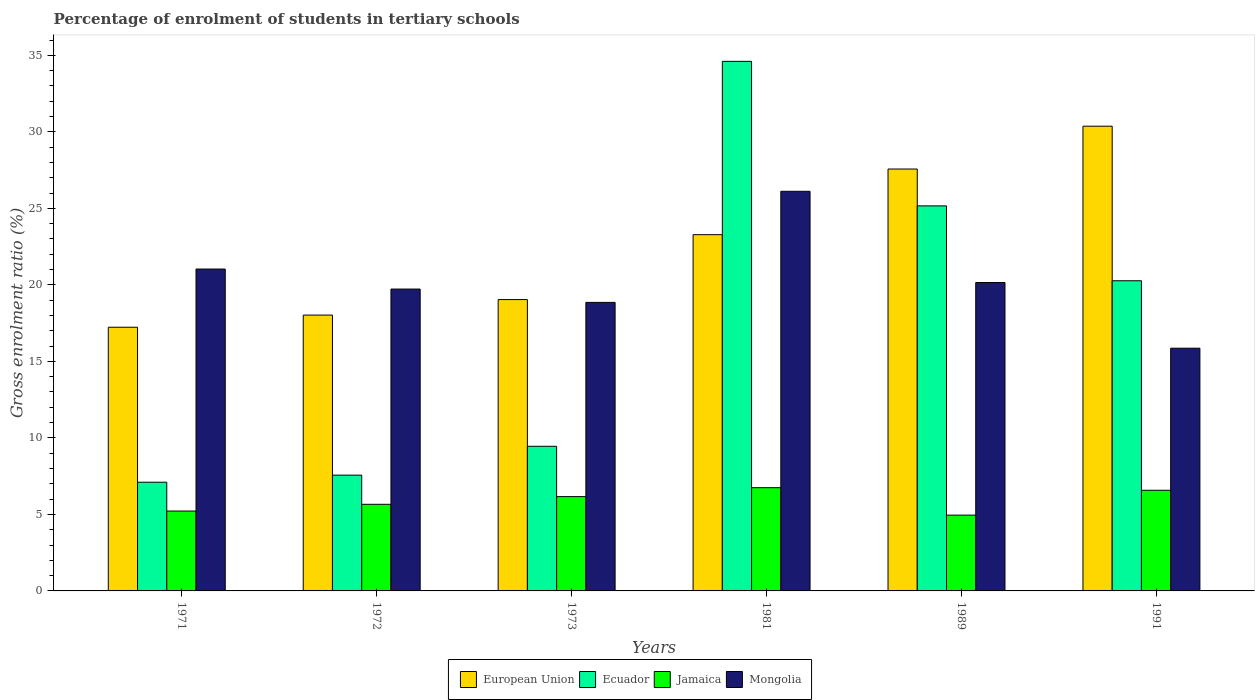How many different coloured bars are there?
Your response must be concise. 4. How many groups of bars are there?
Offer a terse response. 6. How many bars are there on the 2nd tick from the left?
Provide a succinct answer. 4. In how many cases, is the number of bars for a given year not equal to the number of legend labels?
Provide a succinct answer. 0. What is the percentage of students enrolled in tertiary schools in European Union in 1989?
Make the answer very short. 27.57. Across all years, what is the maximum percentage of students enrolled in tertiary schools in Mongolia?
Ensure brevity in your answer.  26.12. Across all years, what is the minimum percentage of students enrolled in tertiary schools in European Union?
Offer a terse response. 17.23. In which year was the percentage of students enrolled in tertiary schools in Ecuador maximum?
Your answer should be compact. 1981. In which year was the percentage of students enrolled in tertiary schools in European Union minimum?
Give a very brief answer. 1971. What is the total percentage of students enrolled in tertiary schools in Ecuador in the graph?
Give a very brief answer. 104.16. What is the difference between the percentage of students enrolled in tertiary schools in European Union in 1973 and that in 1989?
Make the answer very short. -8.53. What is the difference between the percentage of students enrolled in tertiary schools in Mongolia in 1991 and the percentage of students enrolled in tertiary schools in Ecuador in 1972?
Make the answer very short. 8.3. What is the average percentage of students enrolled in tertiary schools in Jamaica per year?
Give a very brief answer. 5.89. In the year 1981, what is the difference between the percentage of students enrolled in tertiary schools in Mongolia and percentage of students enrolled in tertiary schools in Ecuador?
Provide a succinct answer. -8.49. What is the ratio of the percentage of students enrolled in tertiary schools in European Union in 1972 to that in 1989?
Your response must be concise. 0.65. Is the difference between the percentage of students enrolled in tertiary schools in Mongolia in 1989 and 1991 greater than the difference between the percentage of students enrolled in tertiary schools in Ecuador in 1989 and 1991?
Your response must be concise. No. What is the difference between the highest and the second highest percentage of students enrolled in tertiary schools in European Union?
Offer a very short reply. 2.8. What is the difference between the highest and the lowest percentage of students enrolled in tertiary schools in Ecuador?
Your answer should be very brief. 27.5. In how many years, is the percentage of students enrolled in tertiary schools in European Union greater than the average percentage of students enrolled in tertiary schools in European Union taken over all years?
Your response must be concise. 3. Is the sum of the percentage of students enrolled in tertiary schools in Mongolia in 1989 and 1991 greater than the maximum percentage of students enrolled in tertiary schools in Ecuador across all years?
Ensure brevity in your answer.  Yes. Is it the case that in every year, the sum of the percentage of students enrolled in tertiary schools in Mongolia and percentage of students enrolled in tertiary schools in Jamaica is greater than the sum of percentage of students enrolled in tertiary schools in Ecuador and percentage of students enrolled in tertiary schools in European Union?
Offer a very short reply. No. What does the 2nd bar from the right in 1972 represents?
Provide a succinct answer. Jamaica. Is it the case that in every year, the sum of the percentage of students enrolled in tertiary schools in Jamaica and percentage of students enrolled in tertiary schools in European Union is greater than the percentage of students enrolled in tertiary schools in Mongolia?
Your answer should be compact. Yes. How many bars are there?
Your answer should be compact. 24. Are all the bars in the graph horizontal?
Give a very brief answer. No. How many years are there in the graph?
Provide a short and direct response. 6. What is the difference between two consecutive major ticks on the Y-axis?
Give a very brief answer. 5. What is the title of the graph?
Provide a succinct answer. Percentage of enrolment of students in tertiary schools. Does "American Samoa" appear as one of the legend labels in the graph?
Offer a very short reply. No. What is the label or title of the X-axis?
Provide a short and direct response. Years. What is the Gross enrolment ratio (%) in European Union in 1971?
Provide a short and direct response. 17.23. What is the Gross enrolment ratio (%) in Ecuador in 1971?
Offer a terse response. 7.1. What is the Gross enrolment ratio (%) of Jamaica in 1971?
Your answer should be compact. 5.22. What is the Gross enrolment ratio (%) of Mongolia in 1971?
Provide a short and direct response. 21.04. What is the Gross enrolment ratio (%) in European Union in 1972?
Provide a succinct answer. 18.03. What is the Gross enrolment ratio (%) in Ecuador in 1972?
Your response must be concise. 7.57. What is the Gross enrolment ratio (%) in Jamaica in 1972?
Your answer should be very brief. 5.66. What is the Gross enrolment ratio (%) of Mongolia in 1972?
Make the answer very short. 19.73. What is the Gross enrolment ratio (%) of European Union in 1973?
Ensure brevity in your answer.  19.04. What is the Gross enrolment ratio (%) in Ecuador in 1973?
Make the answer very short. 9.45. What is the Gross enrolment ratio (%) of Jamaica in 1973?
Keep it short and to the point. 6.16. What is the Gross enrolment ratio (%) in Mongolia in 1973?
Offer a very short reply. 18.86. What is the Gross enrolment ratio (%) of European Union in 1981?
Make the answer very short. 23.28. What is the Gross enrolment ratio (%) in Ecuador in 1981?
Your answer should be compact. 34.61. What is the Gross enrolment ratio (%) in Jamaica in 1981?
Provide a short and direct response. 6.75. What is the Gross enrolment ratio (%) of Mongolia in 1981?
Provide a short and direct response. 26.12. What is the Gross enrolment ratio (%) in European Union in 1989?
Give a very brief answer. 27.57. What is the Gross enrolment ratio (%) in Ecuador in 1989?
Offer a very short reply. 25.16. What is the Gross enrolment ratio (%) in Jamaica in 1989?
Your answer should be very brief. 4.95. What is the Gross enrolment ratio (%) in Mongolia in 1989?
Provide a succinct answer. 20.16. What is the Gross enrolment ratio (%) of European Union in 1991?
Your answer should be very brief. 30.37. What is the Gross enrolment ratio (%) in Ecuador in 1991?
Keep it short and to the point. 20.27. What is the Gross enrolment ratio (%) of Jamaica in 1991?
Ensure brevity in your answer.  6.58. What is the Gross enrolment ratio (%) of Mongolia in 1991?
Provide a succinct answer. 15.86. Across all years, what is the maximum Gross enrolment ratio (%) in European Union?
Give a very brief answer. 30.37. Across all years, what is the maximum Gross enrolment ratio (%) of Ecuador?
Offer a very short reply. 34.61. Across all years, what is the maximum Gross enrolment ratio (%) in Jamaica?
Keep it short and to the point. 6.75. Across all years, what is the maximum Gross enrolment ratio (%) of Mongolia?
Offer a terse response. 26.12. Across all years, what is the minimum Gross enrolment ratio (%) in European Union?
Offer a terse response. 17.23. Across all years, what is the minimum Gross enrolment ratio (%) of Ecuador?
Keep it short and to the point. 7.1. Across all years, what is the minimum Gross enrolment ratio (%) in Jamaica?
Ensure brevity in your answer.  4.95. Across all years, what is the minimum Gross enrolment ratio (%) of Mongolia?
Your answer should be very brief. 15.86. What is the total Gross enrolment ratio (%) in European Union in the graph?
Offer a terse response. 135.52. What is the total Gross enrolment ratio (%) of Ecuador in the graph?
Your answer should be very brief. 104.16. What is the total Gross enrolment ratio (%) of Jamaica in the graph?
Keep it short and to the point. 35.32. What is the total Gross enrolment ratio (%) in Mongolia in the graph?
Your answer should be compact. 121.75. What is the difference between the Gross enrolment ratio (%) of European Union in 1971 and that in 1972?
Provide a short and direct response. -0.79. What is the difference between the Gross enrolment ratio (%) in Ecuador in 1971 and that in 1972?
Provide a succinct answer. -0.46. What is the difference between the Gross enrolment ratio (%) in Jamaica in 1971 and that in 1972?
Offer a terse response. -0.44. What is the difference between the Gross enrolment ratio (%) of Mongolia in 1971 and that in 1972?
Make the answer very short. 1.31. What is the difference between the Gross enrolment ratio (%) of European Union in 1971 and that in 1973?
Ensure brevity in your answer.  -1.81. What is the difference between the Gross enrolment ratio (%) of Ecuador in 1971 and that in 1973?
Provide a short and direct response. -2.35. What is the difference between the Gross enrolment ratio (%) of Jamaica in 1971 and that in 1973?
Make the answer very short. -0.94. What is the difference between the Gross enrolment ratio (%) of Mongolia in 1971 and that in 1973?
Keep it short and to the point. 2.18. What is the difference between the Gross enrolment ratio (%) in European Union in 1971 and that in 1981?
Keep it short and to the point. -6.05. What is the difference between the Gross enrolment ratio (%) in Ecuador in 1971 and that in 1981?
Ensure brevity in your answer.  -27.5. What is the difference between the Gross enrolment ratio (%) in Jamaica in 1971 and that in 1981?
Give a very brief answer. -1.53. What is the difference between the Gross enrolment ratio (%) of Mongolia in 1971 and that in 1981?
Provide a short and direct response. -5.08. What is the difference between the Gross enrolment ratio (%) of European Union in 1971 and that in 1989?
Your answer should be compact. -10.34. What is the difference between the Gross enrolment ratio (%) of Ecuador in 1971 and that in 1989?
Provide a short and direct response. -18.06. What is the difference between the Gross enrolment ratio (%) of Jamaica in 1971 and that in 1989?
Provide a short and direct response. 0.27. What is the difference between the Gross enrolment ratio (%) in Mongolia in 1971 and that in 1989?
Make the answer very short. 0.88. What is the difference between the Gross enrolment ratio (%) of European Union in 1971 and that in 1991?
Provide a short and direct response. -13.14. What is the difference between the Gross enrolment ratio (%) of Ecuador in 1971 and that in 1991?
Offer a very short reply. -13.17. What is the difference between the Gross enrolment ratio (%) in Jamaica in 1971 and that in 1991?
Make the answer very short. -1.36. What is the difference between the Gross enrolment ratio (%) in Mongolia in 1971 and that in 1991?
Give a very brief answer. 5.17. What is the difference between the Gross enrolment ratio (%) of European Union in 1972 and that in 1973?
Provide a succinct answer. -1.01. What is the difference between the Gross enrolment ratio (%) in Ecuador in 1972 and that in 1973?
Make the answer very short. -1.88. What is the difference between the Gross enrolment ratio (%) in Jamaica in 1972 and that in 1973?
Ensure brevity in your answer.  -0.5. What is the difference between the Gross enrolment ratio (%) in Mongolia in 1972 and that in 1973?
Give a very brief answer. 0.87. What is the difference between the Gross enrolment ratio (%) of European Union in 1972 and that in 1981?
Give a very brief answer. -5.25. What is the difference between the Gross enrolment ratio (%) of Ecuador in 1972 and that in 1981?
Your response must be concise. -27.04. What is the difference between the Gross enrolment ratio (%) in Jamaica in 1972 and that in 1981?
Make the answer very short. -1.08. What is the difference between the Gross enrolment ratio (%) in Mongolia in 1972 and that in 1981?
Offer a very short reply. -6.39. What is the difference between the Gross enrolment ratio (%) of European Union in 1972 and that in 1989?
Provide a short and direct response. -9.54. What is the difference between the Gross enrolment ratio (%) in Ecuador in 1972 and that in 1989?
Ensure brevity in your answer.  -17.6. What is the difference between the Gross enrolment ratio (%) of Jamaica in 1972 and that in 1989?
Offer a very short reply. 0.71. What is the difference between the Gross enrolment ratio (%) in Mongolia in 1972 and that in 1989?
Your answer should be compact. -0.43. What is the difference between the Gross enrolment ratio (%) of European Union in 1972 and that in 1991?
Make the answer very short. -12.34. What is the difference between the Gross enrolment ratio (%) of Ecuador in 1972 and that in 1991?
Offer a terse response. -12.7. What is the difference between the Gross enrolment ratio (%) of Jamaica in 1972 and that in 1991?
Provide a succinct answer. -0.92. What is the difference between the Gross enrolment ratio (%) of Mongolia in 1972 and that in 1991?
Give a very brief answer. 3.86. What is the difference between the Gross enrolment ratio (%) in European Union in 1973 and that in 1981?
Keep it short and to the point. -4.24. What is the difference between the Gross enrolment ratio (%) of Ecuador in 1973 and that in 1981?
Make the answer very short. -25.16. What is the difference between the Gross enrolment ratio (%) of Jamaica in 1973 and that in 1981?
Your answer should be very brief. -0.58. What is the difference between the Gross enrolment ratio (%) of Mongolia in 1973 and that in 1981?
Your answer should be compact. -7.26. What is the difference between the Gross enrolment ratio (%) in European Union in 1973 and that in 1989?
Ensure brevity in your answer.  -8.53. What is the difference between the Gross enrolment ratio (%) of Ecuador in 1973 and that in 1989?
Ensure brevity in your answer.  -15.71. What is the difference between the Gross enrolment ratio (%) of Jamaica in 1973 and that in 1989?
Offer a terse response. 1.21. What is the difference between the Gross enrolment ratio (%) of Mongolia in 1973 and that in 1989?
Your answer should be very brief. -1.3. What is the difference between the Gross enrolment ratio (%) of European Union in 1973 and that in 1991?
Give a very brief answer. -11.33. What is the difference between the Gross enrolment ratio (%) of Ecuador in 1973 and that in 1991?
Offer a terse response. -10.82. What is the difference between the Gross enrolment ratio (%) in Jamaica in 1973 and that in 1991?
Your answer should be very brief. -0.42. What is the difference between the Gross enrolment ratio (%) of Mongolia in 1973 and that in 1991?
Offer a very short reply. 2.99. What is the difference between the Gross enrolment ratio (%) of European Union in 1981 and that in 1989?
Your answer should be very brief. -4.29. What is the difference between the Gross enrolment ratio (%) in Ecuador in 1981 and that in 1989?
Offer a very short reply. 9.45. What is the difference between the Gross enrolment ratio (%) of Jamaica in 1981 and that in 1989?
Make the answer very short. 1.79. What is the difference between the Gross enrolment ratio (%) in Mongolia in 1981 and that in 1989?
Provide a short and direct response. 5.96. What is the difference between the Gross enrolment ratio (%) of European Union in 1981 and that in 1991?
Give a very brief answer. -7.09. What is the difference between the Gross enrolment ratio (%) of Ecuador in 1981 and that in 1991?
Keep it short and to the point. 14.34. What is the difference between the Gross enrolment ratio (%) in Jamaica in 1981 and that in 1991?
Make the answer very short. 0.17. What is the difference between the Gross enrolment ratio (%) of Mongolia in 1981 and that in 1991?
Your answer should be compact. 10.25. What is the difference between the Gross enrolment ratio (%) in European Union in 1989 and that in 1991?
Keep it short and to the point. -2.8. What is the difference between the Gross enrolment ratio (%) of Ecuador in 1989 and that in 1991?
Offer a terse response. 4.89. What is the difference between the Gross enrolment ratio (%) of Jamaica in 1989 and that in 1991?
Keep it short and to the point. -1.62. What is the difference between the Gross enrolment ratio (%) of Mongolia in 1989 and that in 1991?
Ensure brevity in your answer.  4.29. What is the difference between the Gross enrolment ratio (%) of European Union in 1971 and the Gross enrolment ratio (%) of Ecuador in 1972?
Make the answer very short. 9.67. What is the difference between the Gross enrolment ratio (%) in European Union in 1971 and the Gross enrolment ratio (%) in Jamaica in 1972?
Your answer should be very brief. 11.57. What is the difference between the Gross enrolment ratio (%) in European Union in 1971 and the Gross enrolment ratio (%) in Mongolia in 1972?
Your response must be concise. -2.49. What is the difference between the Gross enrolment ratio (%) of Ecuador in 1971 and the Gross enrolment ratio (%) of Jamaica in 1972?
Your answer should be compact. 1.44. What is the difference between the Gross enrolment ratio (%) in Ecuador in 1971 and the Gross enrolment ratio (%) in Mongolia in 1972?
Provide a short and direct response. -12.62. What is the difference between the Gross enrolment ratio (%) in Jamaica in 1971 and the Gross enrolment ratio (%) in Mongolia in 1972?
Your response must be concise. -14.51. What is the difference between the Gross enrolment ratio (%) in European Union in 1971 and the Gross enrolment ratio (%) in Ecuador in 1973?
Make the answer very short. 7.78. What is the difference between the Gross enrolment ratio (%) of European Union in 1971 and the Gross enrolment ratio (%) of Jamaica in 1973?
Your answer should be very brief. 11.07. What is the difference between the Gross enrolment ratio (%) of European Union in 1971 and the Gross enrolment ratio (%) of Mongolia in 1973?
Your response must be concise. -1.62. What is the difference between the Gross enrolment ratio (%) in Ecuador in 1971 and the Gross enrolment ratio (%) in Jamaica in 1973?
Ensure brevity in your answer.  0.94. What is the difference between the Gross enrolment ratio (%) in Ecuador in 1971 and the Gross enrolment ratio (%) in Mongolia in 1973?
Offer a terse response. -11.75. What is the difference between the Gross enrolment ratio (%) of Jamaica in 1971 and the Gross enrolment ratio (%) of Mongolia in 1973?
Give a very brief answer. -13.63. What is the difference between the Gross enrolment ratio (%) in European Union in 1971 and the Gross enrolment ratio (%) in Ecuador in 1981?
Give a very brief answer. -17.38. What is the difference between the Gross enrolment ratio (%) in European Union in 1971 and the Gross enrolment ratio (%) in Jamaica in 1981?
Ensure brevity in your answer.  10.49. What is the difference between the Gross enrolment ratio (%) in European Union in 1971 and the Gross enrolment ratio (%) in Mongolia in 1981?
Offer a terse response. -8.88. What is the difference between the Gross enrolment ratio (%) of Ecuador in 1971 and the Gross enrolment ratio (%) of Jamaica in 1981?
Your answer should be compact. 0.36. What is the difference between the Gross enrolment ratio (%) in Ecuador in 1971 and the Gross enrolment ratio (%) in Mongolia in 1981?
Your answer should be compact. -19.01. What is the difference between the Gross enrolment ratio (%) of Jamaica in 1971 and the Gross enrolment ratio (%) of Mongolia in 1981?
Offer a very short reply. -20.9. What is the difference between the Gross enrolment ratio (%) in European Union in 1971 and the Gross enrolment ratio (%) in Ecuador in 1989?
Ensure brevity in your answer.  -7.93. What is the difference between the Gross enrolment ratio (%) of European Union in 1971 and the Gross enrolment ratio (%) of Jamaica in 1989?
Offer a very short reply. 12.28. What is the difference between the Gross enrolment ratio (%) of European Union in 1971 and the Gross enrolment ratio (%) of Mongolia in 1989?
Provide a short and direct response. -2.92. What is the difference between the Gross enrolment ratio (%) in Ecuador in 1971 and the Gross enrolment ratio (%) in Jamaica in 1989?
Your answer should be very brief. 2.15. What is the difference between the Gross enrolment ratio (%) in Ecuador in 1971 and the Gross enrolment ratio (%) in Mongolia in 1989?
Offer a very short reply. -13.05. What is the difference between the Gross enrolment ratio (%) of Jamaica in 1971 and the Gross enrolment ratio (%) of Mongolia in 1989?
Keep it short and to the point. -14.94. What is the difference between the Gross enrolment ratio (%) of European Union in 1971 and the Gross enrolment ratio (%) of Ecuador in 1991?
Provide a succinct answer. -3.04. What is the difference between the Gross enrolment ratio (%) in European Union in 1971 and the Gross enrolment ratio (%) in Jamaica in 1991?
Ensure brevity in your answer.  10.65. What is the difference between the Gross enrolment ratio (%) of European Union in 1971 and the Gross enrolment ratio (%) of Mongolia in 1991?
Your response must be concise. 1.37. What is the difference between the Gross enrolment ratio (%) in Ecuador in 1971 and the Gross enrolment ratio (%) in Jamaica in 1991?
Your answer should be compact. 0.53. What is the difference between the Gross enrolment ratio (%) in Ecuador in 1971 and the Gross enrolment ratio (%) in Mongolia in 1991?
Make the answer very short. -8.76. What is the difference between the Gross enrolment ratio (%) in Jamaica in 1971 and the Gross enrolment ratio (%) in Mongolia in 1991?
Give a very brief answer. -10.64. What is the difference between the Gross enrolment ratio (%) of European Union in 1972 and the Gross enrolment ratio (%) of Ecuador in 1973?
Provide a short and direct response. 8.58. What is the difference between the Gross enrolment ratio (%) of European Union in 1972 and the Gross enrolment ratio (%) of Jamaica in 1973?
Your response must be concise. 11.86. What is the difference between the Gross enrolment ratio (%) of European Union in 1972 and the Gross enrolment ratio (%) of Mongolia in 1973?
Provide a succinct answer. -0.83. What is the difference between the Gross enrolment ratio (%) in Ecuador in 1972 and the Gross enrolment ratio (%) in Jamaica in 1973?
Provide a succinct answer. 1.4. What is the difference between the Gross enrolment ratio (%) in Ecuador in 1972 and the Gross enrolment ratio (%) in Mongolia in 1973?
Keep it short and to the point. -11.29. What is the difference between the Gross enrolment ratio (%) of Jamaica in 1972 and the Gross enrolment ratio (%) of Mongolia in 1973?
Provide a short and direct response. -13.19. What is the difference between the Gross enrolment ratio (%) in European Union in 1972 and the Gross enrolment ratio (%) in Ecuador in 1981?
Offer a very short reply. -16.58. What is the difference between the Gross enrolment ratio (%) in European Union in 1972 and the Gross enrolment ratio (%) in Jamaica in 1981?
Your response must be concise. 11.28. What is the difference between the Gross enrolment ratio (%) in European Union in 1972 and the Gross enrolment ratio (%) in Mongolia in 1981?
Your response must be concise. -8.09. What is the difference between the Gross enrolment ratio (%) in Ecuador in 1972 and the Gross enrolment ratio (%) in Jamaica in 1981?
Provide a short and direct response. 0.82. What is the difference between the Gross enrolment ratio (%) in Ecuador in 1972 and the Gross enrolment ratio (%) in Mongolia in 1981?
Make the answer very short. -18.55. What is the difference between the Gross enrolment ratio (%) in Jamaica in 1972 and the Gross enrolment ratio (%) in Mongolia in 1981?
Your response must be concise. -20.46. What is the difference between the Gross enrolment ratio (%) in European Union in 1972 and the Gross enrolment ratio (%) in Ecuador in 1989?
Ensure brevity in your answer.  -7.14. What is the difference between the Gross enrolment ratio (%) of European Union in 1972 and the Gross enrolment ratio (%) of Jamaica in 1989?
Your answer should be compact. 13.07. What is the difference between the Gross enrolment ratio (%) in European Union in 1972 and the Gross enrolment ratio (%) in Mongolia in 1989?
Provide a short and direct response. -2.13. What is the difference between the Gross enrolment ratio (%) of Ecuador in 1972 and the Gross enrolment ratio (%) of Jamaica in 1989?
Provide a short and direct response. 2.61. What is the difference between the Gross enrolment ratio (%) of Ecuador in 1972 and the Gross enrolment ratio (%) of Mongolia in 1989?
Keep it short and to the point. -12.59. What is the difference between the Gross enrolment ratio (%) in Jamaica in 1972 and the Gross enrolment ratio (%) in Mongolia in 1989?
Offer a terse response. -14.49. What is the difference between the Gross enrolment ratio (%) in European Union in 1972 and the Gross enrolment ratio (%) in Ecuador in 1991?
Your response must be concise. -2.24. What is the difference between the Gross enrolment ratio (%) of European Union in 1972 and the Gross enrolment ratio (%) of Jamaica in 1991?
Make the answer very short. 11.45. What is the difference between the Gross enrolment ratio (%) in European Union in 1972 and the Gross enrolment ratio (%) in Mongolia in 1991?
Your answer should be compact. 2.16. What is the difference between the Gross enrolment ratio (%) of Ecuador in 1972 and the Gross enrolment ratio (%) of Mongolia in 1991?
Provide a short and direct response. -8.3. What is the difference between the Gross enrolment ratio (%) in Jamaica in 1972 and the Gross enrolment ratio (%) in Mongolia in 1991?
Provide a short and direct response. -10.2. What is the difference between the Gross enrolment ratio (%) in European Union in 1973 and the Gross enrolment ratio (%) in Ecuador in 1981?
Your answer should be compact. -15.57. What is the difference between the Gross enrolment ratio (%) of European Union in 1973 and the Gross enrolment ratio (%) of Jamaica in 1981?
Offer a terse response. 12.29. What is the difference between the Gross enrolment ratio (%) of European Union in 1973 and the Gross enrolment ratio (%) of Mongolia in 1981?
Your answer should be compact. -7.08. What is the difference between the Gross enrolment ratio (%) of Ecuador in 1973 and the Gross enrolment ratio (%) of Jamaica in 1981?
Offer a terse response. 2.71. What is the difference between the Gross enrolment ratio (%) in Ecuador in 1973 and the Gross enrolment ratio (%) in Mongolia in 1981?
Ensure brevity in your answer.  -16.67. What is the difference between the Gross enrolment ratio (%) in Jamaica in 1973 and the Gross enrolment ratio (%) in Mongolia in 1981?
Your answer should be compact. -19.95. What is the difference between the Gross enrolment ratio (%) of European Union in 1973 and the Gross enrolment ratio (%) of Ecuador in 1989?
Provide a short and direct response. -6.12. What is the difference between the Gross enrolment ratio (%) in European Union in 1973 and the Gross enrolment ratio (%) in Jamaica in 1989?
Provide a succinct answer. 14.09. What is the difference between the Gross enrolment ratio (%) in European Union in 1973 and the Gross enrolment ratio (%) in Mongolia in 1989?
Keep it short and to the point. -1.12. What is the difference between the Gross enrolment ratio (%) in Ecuador in 1973 and the Gross enrolment ratio (%) in Jamaica in 1989?
Provide a short and direct response. 4.5. What is the difference between the Gross enrolment ratio (%) in Ecuador in 1973 and the Gross enrolment ratio (%) in Mongolia in 1989?
Give a very brief answer. -10.7. What is the difference between the Gross enrolment ratio (%) in Jamaica in 1973 and the Gross enrolment ratio (%) in Mongolia in 1989?
Your answer should be compact. -13.99. What is the difference between the Gross enrolment ratio (%) of European Union in 1973 and the Gross enrolment ratio (%) of Ecuador in 1991?
Give a very brief answer. -1.23. What is the difference between the Gross enrolment ratio (%) of European Union in 1973 and the Gross enrolment ratio (%) of Jamaica in 1991?
Offer a terse response. 12.46. What is the difference between the Gross enrolment ratio (%) of European Union in 1973 and the Gross enrolment ratio (%) of Mongolia in 1991?
Give a very brief answer. 3.18. What is the difference between the Gross enrolment ratio (%) of Ecuador in 1973 and the Gross enrolment ratio (%) of Jamaica in 1991?
Provide a short and direct response. 2.87. What is the difference between the Gross enrolment ratio (%) of Ecuador in 1973 and the Gross enrolment ratio (%) of Mongolia in 1991?
Keep it short and to the point. -6.41. What is the difference between the Gross enrolment ratio (%) of Jamaica in 1973 and the Gross enrolment ratio (%) of Mongolia in 1991?
Offer a terse response. -9.7. What is the difference between the Gross enrolment ratio (%) in European Union in 1981 and the Gross enrolment ratio (%) in Ecuador in 1989?
Provide a succinct answer. -1.88. What is the difference between the Gross enrolment ratio (%) of European Union in 1981 and the Gross enrolment ratio (%) of Jamaica in 1989?
Offer a very short reply. 18.33. What is the difference between the Gross enrolment ratio (%) in European Union in 1981 and the Gross enrolment ratio (%) in Mongolia in 1989?
Provide a succinct answer. 3.13. What is the difference between the Gross enrolment ratio (%) in Ecuador in 1981 and the Gross enrolment ratio (%) in Jamaica in 1989?
Ensure brevity in your answer.  29.66. What is the difference between the Gross enrolment ratio (%) of Ecuador in 1981 and the Gross enrolment ratio (%) of Mongolia in 1989?
Provide a short and direct response. 14.45. What is the difference between the Gross enrolment ratio (%) in Jamaica in 1981 and the Gross enrolment ratio (%) in Mongolia in 1989?
Offer a terse response. -13.41. What is the difference between the Gross enrolment ratio (%) in European Union in 1981 and the Gross enrolment ratio (%) in Ecuador in 1991?
Offer a very short reply. 3.01. What is the difference between the Gross enrolment ratio (%) of European Union in 1981 and the Gross enrolment ratio (%) of Jamaica in 1991?
Your response must be concise. 16.7. What is the difference between the Gross enrolment ratio (%) in European Union in 1981 and the Gross enrolment ratio (%) in Mongolia in 1991?
Your answer should be compact. 7.42. What is the difference between the Gross enrolment ratio (%) of Ecuador in 1981 and the Gross enrolment ratio (%) of Jamaica in 1991?
Offer a terse response. 28.03. What is the difference between the Gross enrolment ratio (%) in Ecuador in 1981 and the Gross enrolment ratio (%) in Mongolia in 1991?
Your response must be concise. 18.75. What is the difference between the Gross enrolment ratio (%) of Jamaica in 1981 and the Gross enrolment ratio (%) of Mongolia in 1991?
Ensure brevity in your answer.  -9.12. What is the difference between the Gross enrolment ratio (%) of European Union in 1989 and the Gross enrolment ratio (%) of Ecuador in 1991?
Offer a terse response. 7.3. What is the difference between the Gross enrolment ratio (%) of European Union in 1989 and the Gross enrolment ratio (%) of Jamaica in 1991?
Ensure brevity in your answer.  20.99. What is the difference between the Gross enrolment ratio (%) in European Union in 1989 and the Gross enrolment ratio (%) in Mongolia in 1991?
Keep it short and to the point. 11.71. What is the difference between the Gross enrolment ratio (%) in Ecuador in 1989 and the Gross enrolment ratio (%) in Jamaica in 1991?
Your response must be concise. 18.59. What is the difference between the Gross enrolment ratio (%) in Ecuador in 1989 and the Gross enrolment ratio (%) in Mongolia in 1991?
Make the answer very short. 9.3. What is the difference between the Gross enrolment ratio (%) in Jamaica in 1989 and the Gross enrolment ratio (%) in Mongolia in 1991?
Keep it short and to the point. -10.91. What is the average Gross enrolment ratio (%) in European Union per year?
Offer a very short reply. 22.59. What is the average Gross enrolment ratio (%) of Ecuador per year?
Provide a short and direct response. 17.36. What is the average Gross enrolment ratio (%) in Jamaica per year?
Provide a short and direct response. 5.89. What is the average Gross enrolment ratio (%) in Mongolia per year?
Offer a very short reply. 20.29. In the year 1971, what is the difference between the Gross enrolment ratio (%) in European Union and Gross enrolment ratio (%) in Ecuador?
Offer a terse response. 10.13. In the year 1971, what is the difference between the Gross enrolment ratio (%) of European Union and Gross enrolment ratio (%) of Jamaica?
Keep it short and to the point. 12.01. In the year 1971, what is the difference between the Gross enrolment ratio (%) in European Union and Gross enrolment ratio (%) in Mongolia?
Ensure brevity in your answer.  -3.8. In the year 1971, what is the difference between the Gross enrolment ratio (%) of Ecuador and Gross enrolment ratio (%) of Jamaica?
Your answer should be compact. 1.88. In the year 1971, what is the difference between the Gross enrolment ratio (%) of Ecuador and Gross enrolment ratio (%) of Mongolia?
Ensure brevity in your answer.  -13.93. In the year 1971, what is the difference between the Gross enrolment ratio (%) of Jamaica and Gross enrolment ratio (%) of Mongolia?
Offer a terse response. -15.82. In the year 1972, what is the difference between the Gross enrolment ratio (%) of European Union and Gross enrolment ratio (%) of Ecuador?
Offer a very short reply. 10.46. In the year 1972, what is the difference between the Gross enrolment ratio (%) in European Union and Gross enrolment ratio (%) in Jamaica?
Your response must be concise. 12.37. In the year 1972, what is the difference between the Gross enrolment ratio (%) of European Union and Gross enrolment ratio (%) of Mongolia?
Your answer should be very brief. -1.7. In the year 1972, what is the difference between the Gross enrolment ratio (%) in Ecuador and Gross enrolment ratio (%) in Jamaica?
Provide a short and direct response. 1.91. In the year 1972, what is the difference between the Gross enrolment ratio (%) in Ecuador and Gross enrolment ratio (%) in Mongolia?
Your response must be concise. -12.16. In the year 1972, what is the difference between the Gross enrolment ratio (%) in Jamaica and Gross enrolment ratio (%) in Mongolia?
Offer a very short reply. -14.07. In the year 1973, what is the difference between the Gross enrolment ratio (%) in European Union and Gross enrolment ratio (%) in Ecuador?
Provide a succinct answer. 9.59. In the year 1973, what is the difference between the Gross enrolment ratio (%) of European Union and Gross enrolment ratio (%) of Jamaica?
Give a very brief answer. 12.88. In the year 1973, what is the difference between the Gross enrolment ratio (%) in European Union and Gross enrolment ratio (%) in Mongolia?
Your response must be concise. 0.18. In the year 1973, what is the difference between the Gross enrolment ratio (%) of Ecuador and Gross enrolment ratio (%) of Jamaica?
Offer a very short reply. 3.29. In the year 1973, what is the difference between the Gross enrolment ratio (%) of Ecuador and Gross enrolment ratio (%) of Mongolia?
Ensure brevity in your answer.  -9.4. In the year 1973, what is the difference between the Gross enrolment ratio (%) of Jamaica and Gross enrolment ratio (%) of Mongolia?
Your response must be concise. -12.69. In the year 1981, what is the difference between the Gross enrolment ratio (%) in European Union and Gross enrolment ratio (%) in Ecuador?
Offer a terse response. -11.33. In the year 1981, what is the difference between the Gross enrolment ratio (%) in European Union and Gross enrolment ratio (%) in Jamaica?
Your response must be concise. 16.54. In the year 1981, what is the difference between the Gross enrolment ratio (%) of European Union and Gross enrolment ratio (%) of Mongolia?
Keep it short and to the point. -2.84. In the year 1981, what is the difference between the Gross enrolment ratio (%) in Ecuador and Gross enrolment ratio (%) in Jamaica?
Give a very brief answer. 27.86. In the year 1981, what is the difference between the Gross enrolment ratio (%) of Ecuador and Gross enrolment ratio (%) of Mongolia?
Give a very brief answer. 8.49. In the year 1981, what is the difference between the Gross enrolment ratio (%) in Jamaica and Gross enrolment ratio (%) in Mongolia?
Make the answer very short. -19.37. In the year 1989, what is the difference between the Gross enrolment ratio (%) in European Union and Gross enrolment ratio (%) in Ecuador?
Provide a succinct answer. 2.41. In the year 1989, what is the difference between the Gross enrolment ratio (%) in European Union and Gross enrolment ratio (%) in Jamaica?
Your response must be concise. 22.62. In the year 1989, what is the difference between the Gross enrolment ratio (%) of European Union and Gross enrolment ratio (%) of Mongolia?
Offer a very short reply. 7.42. In the year 1989, what is the difference between the Gross enrolment ratio (%) in Ecuador and Gross enrolment ratio (%) in Jamaica?
Provide a short and direct response. 20.21. In the year 1989, what is the difference between the Gross enrolment ratio (%) in Ecuador and Gross enrolment ratio (%) in Mongolia?
Provide a succinct answer. 5.01. In the year 1989, what is the difference between the Gross enrolment ratio (%) in Jamaica and Gross enrolment ratio (%) in Mongolia?
Your response must be concise. -15.2. In the year 1991, what is the difference between the Gross enrolment ratio (%) in European Union and Gross enrolment ratio (%) in Ecuador?
Your answer should be compact. 10.1. In the year 1991, what is the difference between the Gross enrolment ratio (%) in European Union and Gross enrolment ratio (%) in Jamaica?
Keep it short and to the point. 23.79. In the year 1991, what is the difference between the Gross enrolment ratio (%) in European Union and Gross enrolment ratio (%) in Mongolia?
Give a very brief answer. 14.51. In the year 1991, what is the difference between the Gross enrolment ratio (%) of Ecuador and Gross enrolment ratio (%) of Jamaica?
Offer a terse response. 13.69. In the year 1991, what is the difference between the Gross enrolment ratio (%) in Ecuador and Gross enrolment ratio (%) in Mongolia?
Your answer should be very brief. 4.41. In the year 1991, what is the difference between the Gross enrolment ratio (%) in Jamaica and Gross enrolment ratio (%) in Mongolia?
Make the answer very short. -9.28. What is the ratio of the Gross enrolment ratio (%) in European Union in 1971 to that in 1972?
Give a very brief answer. 0.96. What is the ratio of the Gross enrolment ratio (%) in Ecuador in 1971 to that in 1972?
Make the answer very short. 0.94. What is the ratio of the Gross enrolment ratio (%) in Jamaica in 1971 to that in 1972?
Your response must be concise. 0.92. What is the ratio of the Gross enrolment ratio (%) in Mongolia in 1971 to that in 1972?
Offer a terse response. 1.07. What is the ratio of the Gross enrolment ratio (%) of European Union in 1971 to that in 1973?
Offer a terse response. 0.91. What is the ratio of the Gross enrolment ratio (%) of Ecuador in 1971 to that in 1973?
Offer a terse response. 0.75. What is the ratio of the Gross enrolment ratio (%) of Jamaica in 1971 to that in 1973?
Provide a succinct answer. 0.85. What is the ratio of the Gross enrolment ratio (%) in Mongolia in 1971 to that in 1973?
Your response must be concise. 1.12. What is the ratio of the Gross enrolment ratio (%) of European Union in 1971 to that in 1981?
Keep it short and to the point. 0.74. What is the ratio of the Gross enrolment ratio (%) in Ecuador in 1971 to that in 1981?
Your response must be concise. 0.21. What is the ratio of the Gross enrolment ratio (%) in Jamaica in 1971 to that in 1981?
Keep it short and to the point. 0.77. What is the ratio of the Gross enrolment ratio (%) in Mongolia in 1971 to that in 1981?
Your response must be concise. 0.81. What is the ratio of the Gross enrolment ratio (%) of Ecuador in 1971 to that in 1989?
Your answer should be compact. 0.28. What is the ratio of the Gross enrolment ratio (%) of Jamaica in 1971 to that in 1989?
Offer a very short reply. 1.05. What is the ratio of the Gross enrolment ratio (%) of Mongolia in 1971 to that in 1989?
Your answer should be very brief. 1.04. What is the ratio of the Gross enrolment ratio (%) of European Union in 1971 to that in 1991?
Your response must be concise. 0.57. What is the ratio of the Gross enrolment ratio (%) in Ecuador in 1971 to that in 1991?
Ensure brevity in your answer.  0.35. What is the ratio of the Gross enrolment ratio (%) of Jamaica in 1971 to that in 1991?
Ensure brevity in your answer.  0.79. What is the ratio of the Gross enrolment ratio (%) of Mongolia in 1971 to that in 1991?
Give a very brief answer. 1.33. What is the ratio of the Gross enrolment ratio (%) of European Union in 1972 to that in 1973?
Your answer should be very brief. 0.95. What is the ratio of the Gross enrolment ratio (%) in Ecuador in 1972 to that in 1973?
Keep it short and to the point. 0.8. What is the ratio of the Gross enrolment ratio (%) of Jamaica in 1972 to that in 1973?
Your answer should be compact. 0.92. What is the ratio of the Gross enrolment ratio (%) of Mongolia in 1972 to that in 1973?
Your answer should be very brief. 1.05. What is the ratio of the Gross enrolment ratio (%) of European Union in 1972 to that in 1981?
Give a very brief answer. 0.77. What is the ratio of the Gross enrolment ratio (%) of Ecuador in 1972 to that in 1981?
Your answer should be very brief. 0.22. What is the ratio of the Gross enrolment ratio (%) of Jamaica in 1972 to that in 1981?
Your answer should be compact. 0.84. What is the ratio of the Gross enrolment ratio (%) in Mongolia in 1972 to that in 1981?
Your answer should be compact. 0.76. What is the ratio of the Gross enrolment ratio (%) in European Union in 1972 to that in 1989?
Your response must be concise. 0.65. What is the ratio of the Gross enrolment ratio (%) of Ecuador in 1972 to that in 1989?
Give a very brief answer. 0.3. What is the ratio of the Gross enrolment ratio (%) of Jamaica in 1972 to that in 1989?
Provide a succinct answer. 1.14. What is the ratio of the Gross enrolment ratio (%) in Mongolia in 1972 to that in 1989?
Provide a short and direct response. 0.98. What is the ratio of the Gross enrolment ratio (%) of European Union in 1972 to that in 1991?
Provide a succinct answer. 0.59. What is the ratio of the Gross enrolment ratio (%) of Ecuador in 1972 to that in 1991?
Give a very brief answer. 0.37. What is the ratio of the Gross enrolment ratio (%) of Jamaica in 1972 to that in 1991?
Offer a very short reply. 0.86. What is the ratio of the Gross enrolment ratio (%) in Mongolia in 1972 to that in 1991?
Your answer should be compact. 1.24. What is the ratio of the Gross enrolment ratio (%) of European Union in 1973 to that in 1981?
Give a very brief answer. 0.82. What is the ratio of the Gross enrolment ratio (%) of Ecuador in 1973 to that in 1981?
Give a very brief answer. 0.27. What is the ratio of the Gross enrolment ratio (%) in Jamaica in 1973 to that in 1981?
Your response must be concise. 0.91. What is the ratio of the Gross enrolment ratio (%) in Mongolia in 1973 to that in 1981?
Offer a very short reply. 0.72. What is the ratio of the Gross enrolment ratio (%) in European Union in 1973 to that in 1989?
Your answer should be compact. 0.69. What is the ratio of the Gross enrolment ratio (%) in Ecuador in 1973 to that in 1989?
Offer a very short reply. 0.38. What is the ratio of the Gross enrolment ratio (%) in Jamaica in 1973 to that in 1989?
Your answer should be very brief. 1.24. What is the ratio of the Gross enrolment ratio (%) in Mongolia in 1973 to that in 1989?
Ensure brevity in your answer.  0.94. What is the ratio of the Gross enrolment ratio (%) in European Union in 1973 to that in 1991?
Offer a terse response. 0.63. What is the ratio of the Gross enrolment ratio (%) of Ecuador in 1973 to that in 1991?
Offer a very short reply. 0.47. What is the ratio of the Gross enrolment ratio (%) of Jamaica in 1973 to that in 1991?
Provide a short and direct response. 0.94. What is the ratio of the Gross enrolment ratio (%) in Mongolia in 1973 to that in 1991?
Offer a very short reply. 1.19. What is the ratio of the Gross enrolment ratio (%) in European Union in 1981 to that in 1989?
Keep it short and to the point. 0.84. What is the ratio of the Gross enrolment ratio (%) in Ecuador in 1981 to that in 1989?
Your answer should be very brief. 1.38. What is the ratio of the Gross enrolment ratio (%) in Jamaica in 1981 to that in 1989?
Ensure brevity in your answer.  1.36. What is the ratio of the Gross enrolment ratio (%) of Mongolia in 1981 to that in 1989?
Your response must be concise. 1.3. What is the ratio of the Gross enrolment ratio (%) of European Union in 1981 to that in 1991?
Offer a very short reply. 0.77. What is the ratio of the Gross enrolment ratio (%) of Ecuador in 1981 to that in 1991?
Your answer should be very brief. 1.71. What is the ratio of the Gross enrolment ratio (%) of Jamaica in 1981 to that in 1991?
Give a very brief answer. 1.03. What is the ratio of the Gross enrolment ratio (%) of Mongolia in 1981 to that in 1991?
Offer a terse response. 1.65. What is the ratio of the Gross enrolment ratio (%) of European Union in 1989 to that in 1991?
Your response must be concise. 0.91. What is the ratio of the Gross enrolment ratio (%) in Ecuador in 1989 to that in 1991?
Make the answer very short. 1.24. What is the ratio of the Gross enrolment ratio (%) in Jamaica in 1989 to that in 1991?
Provide a short and direct response. 0.75. What is the ratio of the Gross enrolment ratio (%) of Mongolia in 1989 to that in 1991?
Your response must be concise. 1.27. What is the difference between the highest and the second highest Gross enrolment ratio (%) in European Union?
Provide a succinct answer. 2.8. What is the difference between the highest and the second highest Gross enrolment ratio (%) of Ecuador?
Ensure brevity in your answer.  9.45. What is the difference between the highest and the second highest Gross enrolment ratio (%) of Jamaica?
Provide a succinct answer. 0.17. What is the difference between the highest and the second highest Gross enrolment ratio (%) of Mongolia?
Offer a terse response. 5.08. What is the difference between the highest and the lowest Gross enrolment ratio (%) of European Union?
Your response must be concise. 13.14. What is the difference between the highest and the lowest Gross enrolment ratio (%) of Ecuador?
Offer a terse response. 27.5. What is the difference between the highest and the lowest Gross enrolment ratio (%) in Jamaica?
Make the answer very short. 1.79. What is the difference between the highest and the lowest Gross enrolment ratio (%) in Mongolia?
Offer a terse response. 10.25. 